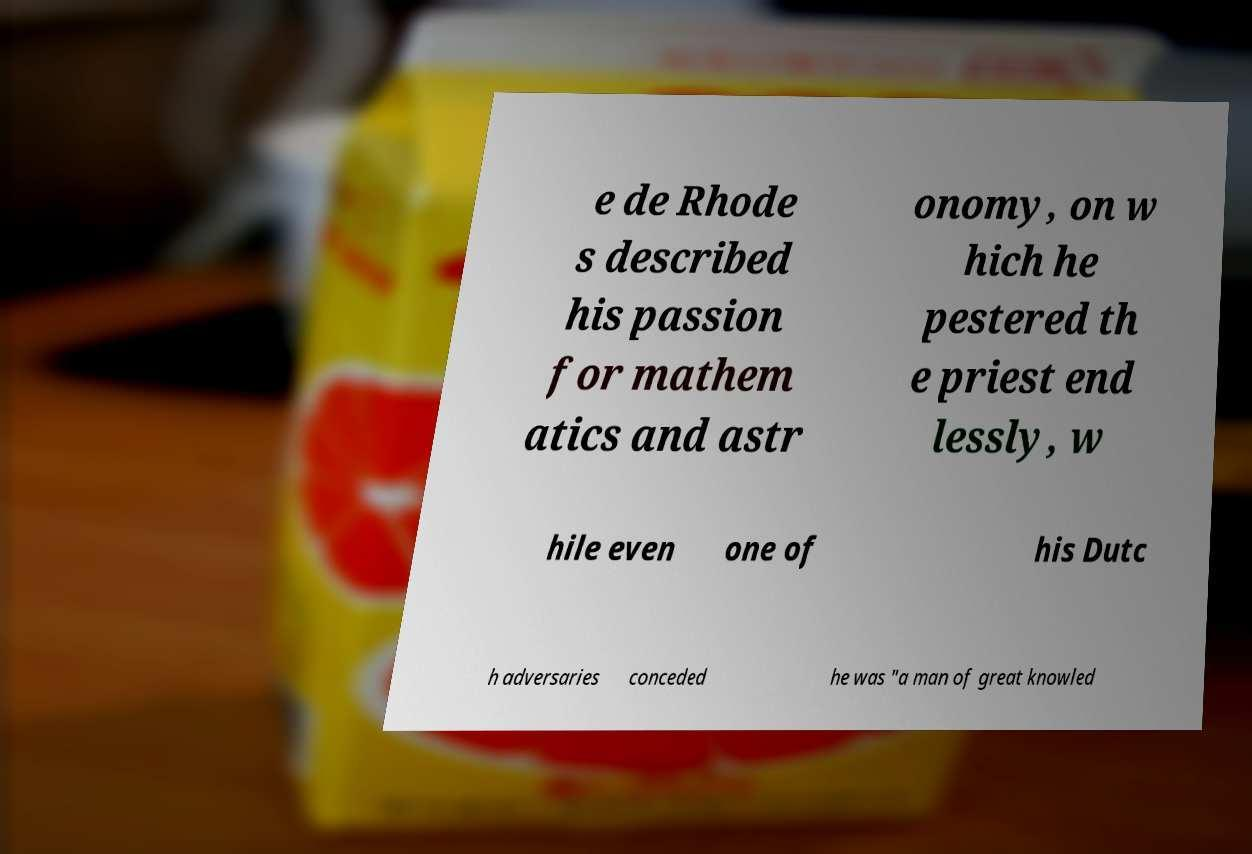Please read and relay the text visible in this image. What does it say? e de Rhode s described his passion for mathem atics and astr onomy, on w hich he pestered th e priest end lessly, w hile even one of his Dutc h adversaries conceded he was "a man of great knowled 